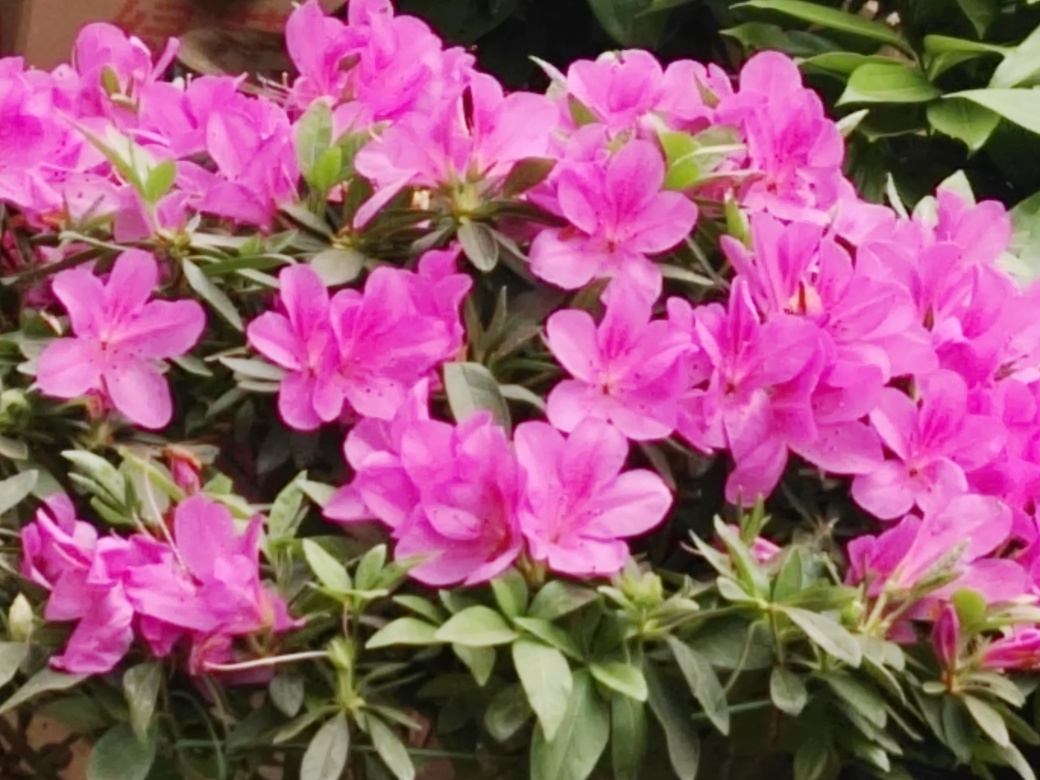What is the quality of the image?
A. Good
B. Bad
C. Outstanding
D. Average The image has a good resolution with vibrant colors and clear details in the flowers. However, there is some blurring toward the edges, suggesting a slight focus issue. So while the visual elements are appealing, there's room for improvement in the sharpness, placing the image quality somewhere between good and outstanding. 